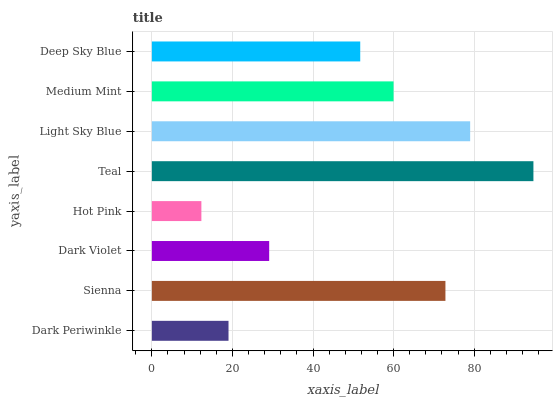Is Hot Pink the minimum?
Answer yes or no. Yes. Is Teal the maximum?
Answer yes or no. Yes. Is Sienna the minimum?
Answer yes or no. No. Is Sienna the maximum?
Answer yes or no. No. Is Sienna greater than Dark Periwinkle?
Answer yes or no. Yes. Is Dark Periwinkle less than Sienna?
Answer yes or no. Yes. Is Dark Periwinkle greater than Sienna?
Answer yes or no. No. Is Sienna less than Dark Periwinkle?
Answer yes or no. No. Is Medium Mint the high median?
Answer yes or no. Yes. Is Deep Sky Blue the low median?
Answer yes or no. Yes. Is Dark Periwinkle the high median?
Answer yes or no. No. Is Medium Mint the low median?
Answer yes or no. No. 